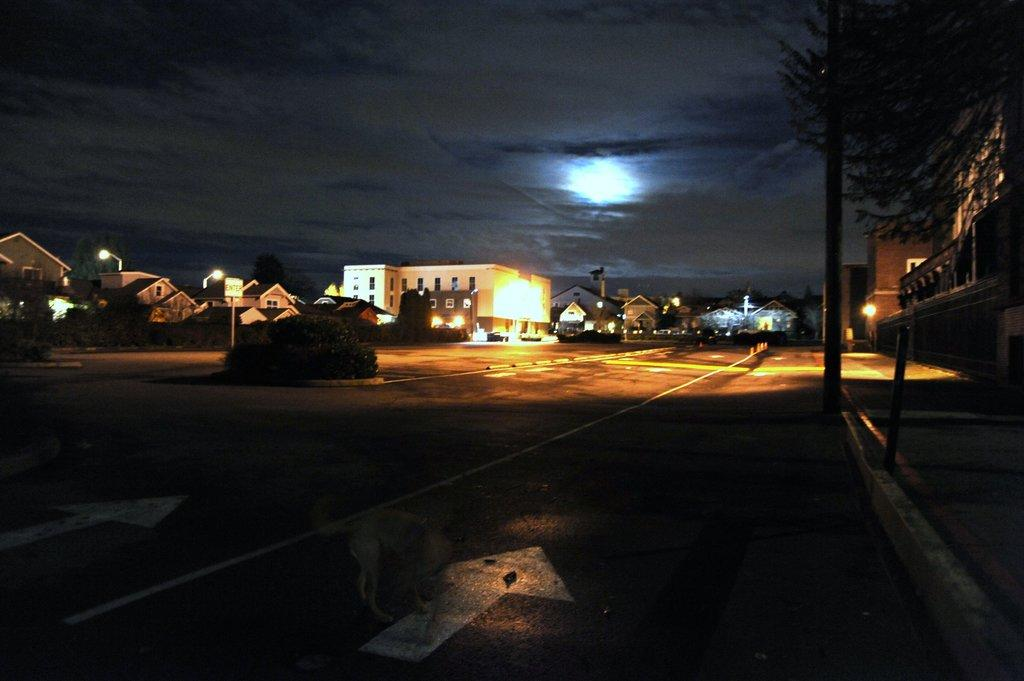What can be seen on the left side of the image? There is a road on the left side of the image. What is located on the right side of the image? There is a footpath on the right side of the image, and there are buildings on the right side as well. What is visible in the background of the image? There are buildings in the background of the image. What can be seen in the sky in the image? The moon is visible in the sky, along with clouds. What type of flower is growing on the footpath in the image? There are no flowers visible on the footpath in the image. Can you see a zipper on any of the buildings in the image? There is no zipper present on any of the buildings in the image. 